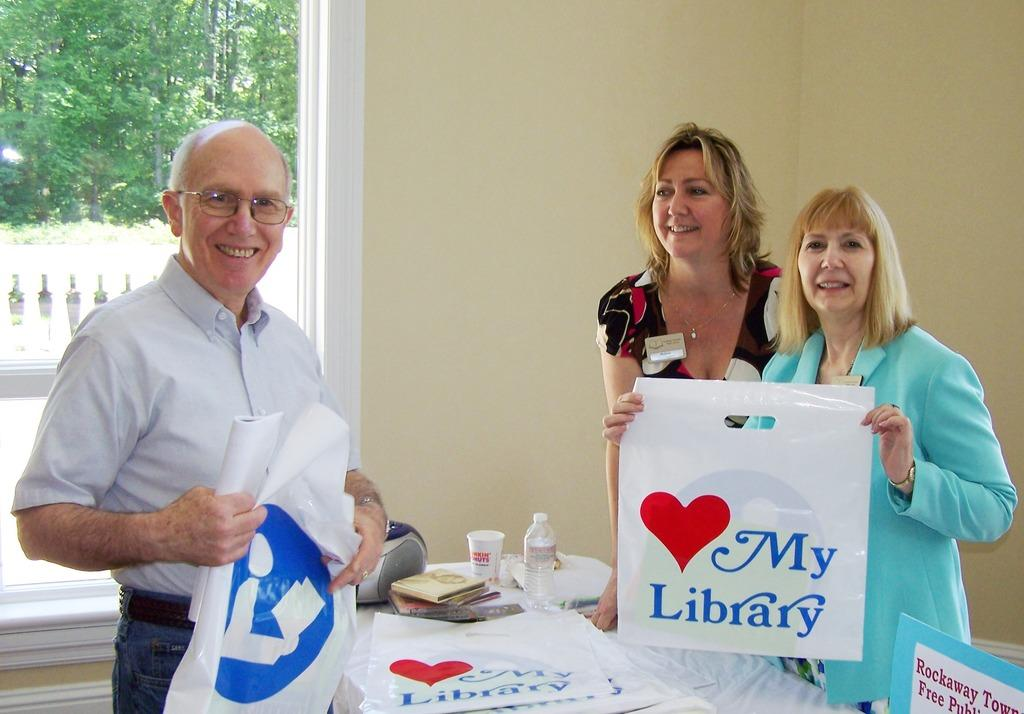Provide a one-sentence caption for the provided image. Two woman holding a bag that says love my library. 